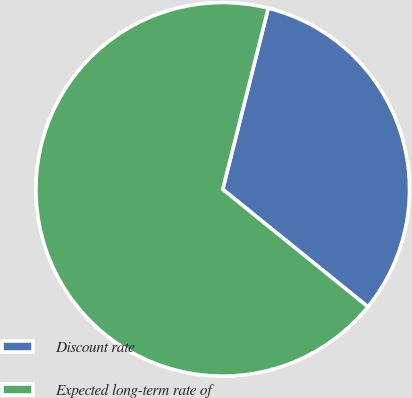Convert chart to OTSL. <chart><loc_0><loc_0><loc_500><loc_500><pie_chart><fcel>Discount rate<fcel>Expected long-term rate of<nl><fcel>31.91%<fcel>68.09%<nl></chart> 